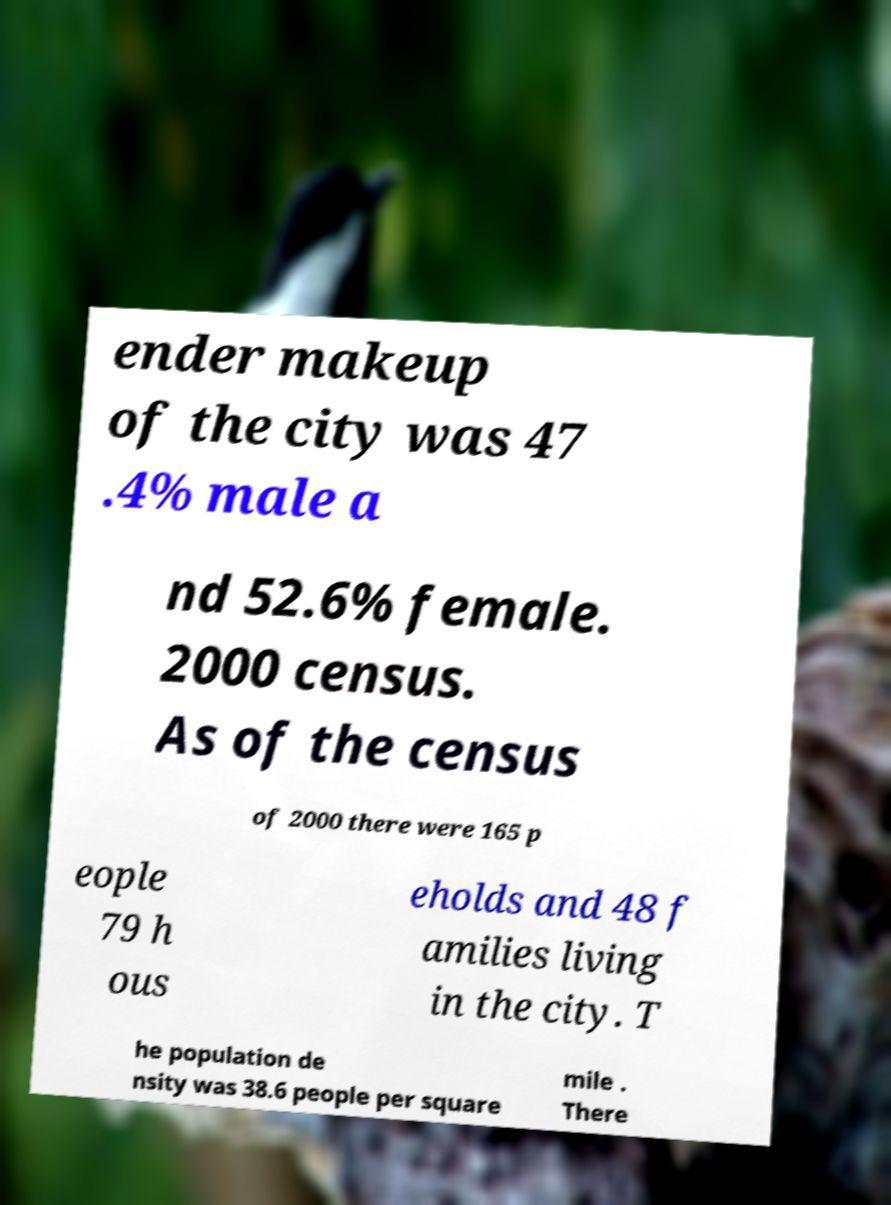Please identify and transcribe the text found in this image. ender makeup of the city was 47 .4% male a nd 52.6% female. 2000 census. As of the census of 2000 there were 165 p eople 79 h ous eholds and 48 f amilies living in the city. T he population de nsity was 38.6 people per square mile . There 